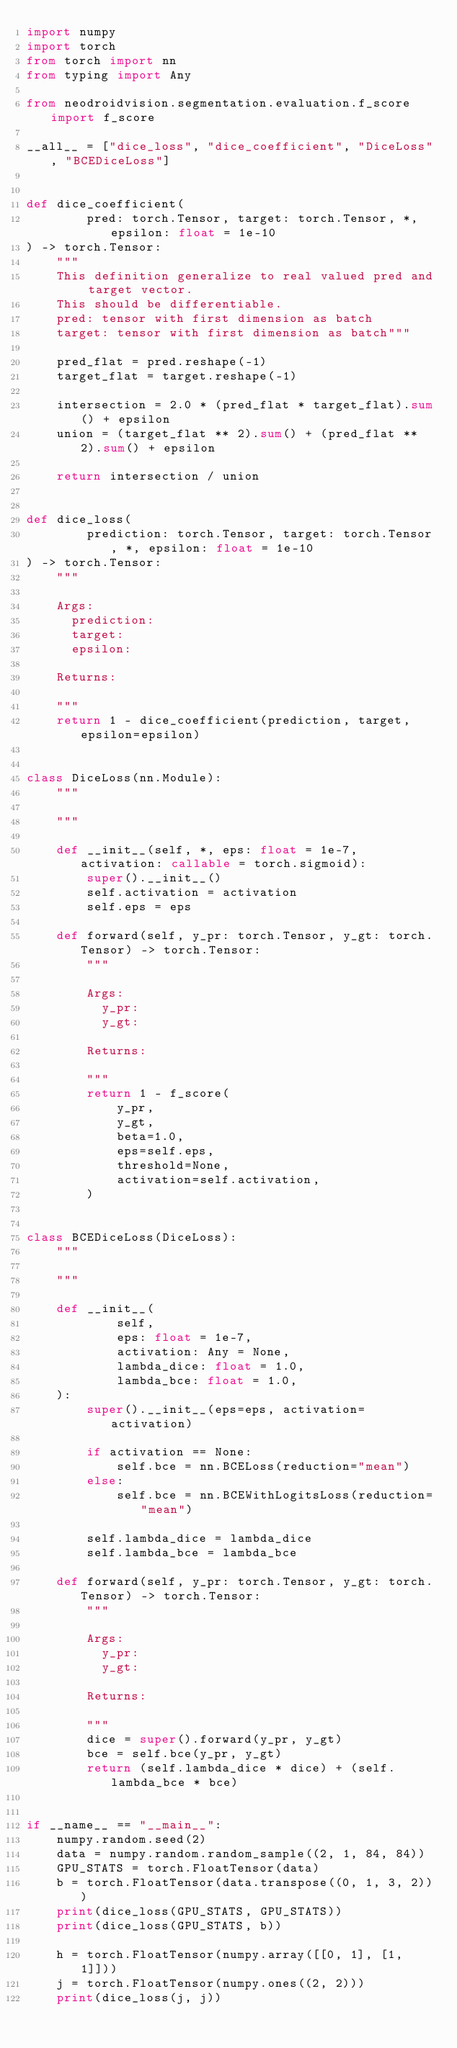<code> <loc_0><loc_0><loc_500><loc_500><_Python_>import numpy
import torch
from torch import nn
from typing import Any

from neodroidvision.segmentation.evaluation.f_score import f_score

__all__ = ["dice_loss", "dice_coefficient", "DiceLoss", "BCEDiceLoss"]


def dice_coefficient(
        pred: torch.Tensor, target: torch.Tensor, *, epsilon: float = 1e-10
) -> torch.Tensor:
    """
    This definition generalize to real valued pred and target vector.
    This should be differentiable.
    pred: tensor with first dimension as batch
    target: tensor with first dimension as batch"""

    pred_flat = pred.reshape(-1)
    target_flat = target.reshape(-1)

    intersection = 2.0 * (pred_flat * target_flat).sum() + epsilon
    union = (target_flat ** 2).sum() + (pred_flat ** 2).sum() + epsilon

    return intersection / union


def dice_loss(
        prediction: torch.Tensor, target: torch.Tensor, *, epsilon: float = 1e-10
) -> torch.Tensor:
    """

    Args:
      prediction:
      target:
      epsilon:

    Returns:

    """
    return 1 - dice_coefficient(prediction, target, epsilon=epsilon)


class DiceLoss(nn.Module):
    """

    """

    def __init__(self, *, eps: float = 1e-7, activation: callable = torch.sigmoid):
        super().__init__()
        self.activation = activation
        self.eps = eps

    def forward(self, y_pr: torch.Tensor, y_gt: torch.Tensor) -> torch.Tensor:
        """

        Args:
          y_pr:
          y_gt:

        Returns:

        """
        return 1 - f_score(
            y_pr,
            y_gt,
            beta=1.0,
            eps=self.eps,
            threshold=None,
            activation=self.activation,
        )


class BCEDiceLoss(DiceLoss):
    """

    """

    def __init__(
            self,
            eps: float = 1e-7,
            activation: Any = None,
            lambda_dice: float = 1.0,
            lambda_bce: float = 1.0,
    ):
        super().__init__(eps=eps, activation=activation)

        if activation == None:
            self.bce = nn.BCELoss(reduction="mean")
        else:
            self.bce = nn.BCEWithLogitsLoss(reduction="mean")

        self.lambda_dice = lambda_dice
        self.lambda_bce = lambda_bce

    def forward(self, y_pr: torch.Tensor, y_gt: torch.Tensor) -> torch.Tensor:
        """

        Args:
          y_pr:
          y_gt:

        Returns:

        """
        dice = super().forward(y_pr, y_gt)
        bce = self.bce(y_pr, y_gt)
        return (self.lambda_dice * dice) + (self.lambda_bce * bce)


if __name__ == "__main__":
    numpy.random.seed(2)
    data = numpy.random.random_sample((2, 1, 84, 84))
    GPU_STATS = torch.FloatTensor(data)
    b = torch.FloatTensor(data.transpose((0, 1, 3, 2)))
    print(dice_loss(GPU_STATS, GPU_STATS))
    print(dice_loss(GPU_STATS, b))

    h = torch.FloatTensor(numpy.array([[0, 1], [1, 1]]))
    j = torch.FloatTensor(numpy.ones((2, 2)))
    print(dice_loss(j, j))
</code> 